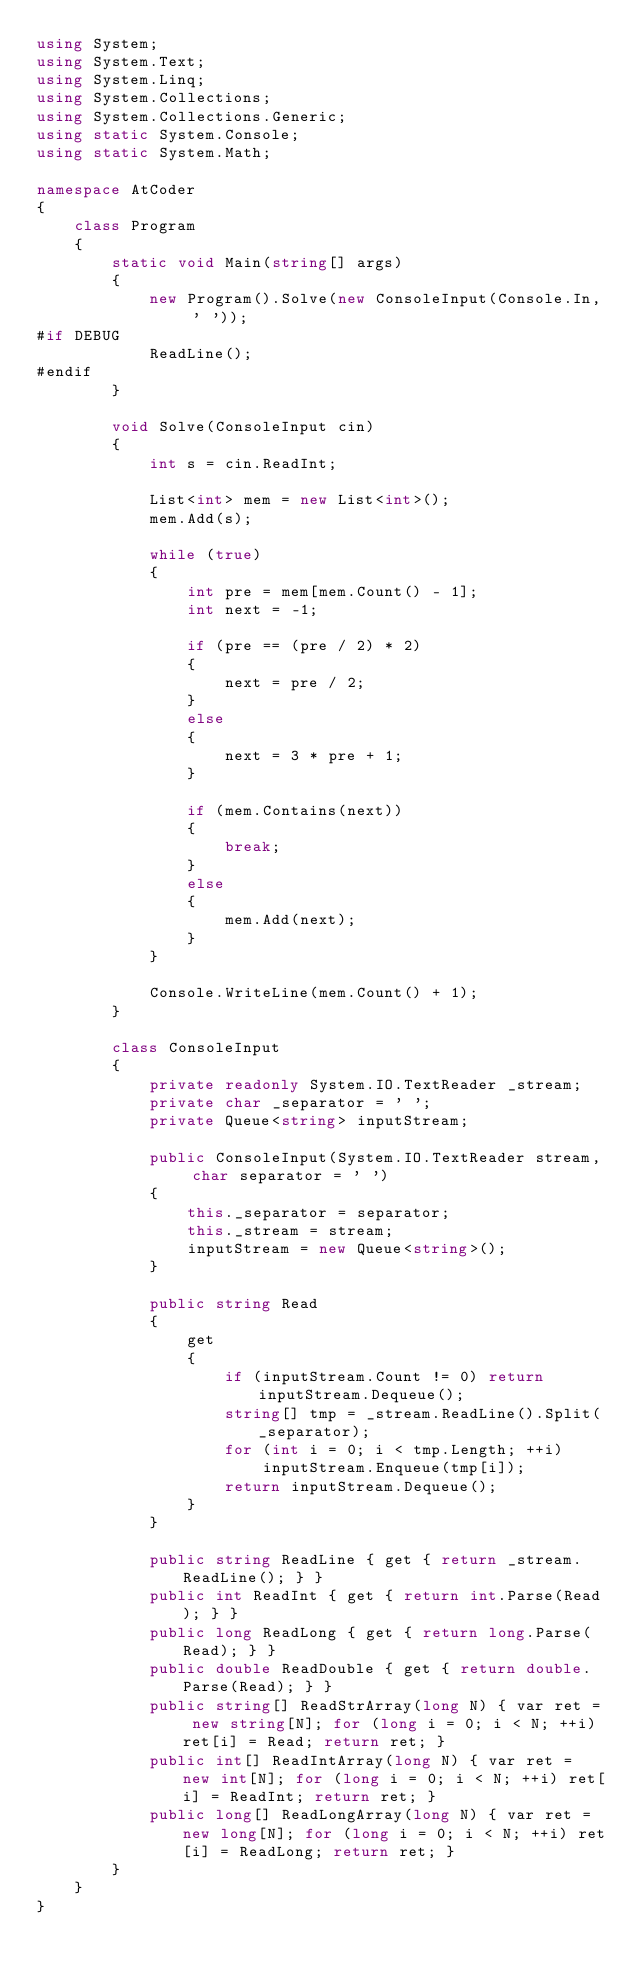<code> <loc_0><loc_0><loc_500><loc_500><_C#_>using System;
using System.Text;
using System.Linq;
using System.Collections;
using System.Collections.Generic;
using static System.Console;
using static System.Math;

namespace AtCoder
{
    class Program
    {
        static void Main(string[] args)
        {
            new Program().Solve(new ConsoleInput(Console.In, ' '));
#if DEBUG
            ReadLine();
#endif
        }

        void Solve(ConsoleInput cin)
        {
            int s = cin.ReadInt;

            List<int> mem = new List<int>();
            mem.Add(s);

            while (true)
            {
                int pre = mem[mem.Count() - 1];
                int next = -1;

                if (pre == (pre / 2) * 2)
                {
                    next = pre / 2;
                }
                else
                {
                    next = 3 * pre + 1;
                }

                if (mem.Contains(next))
                {
                    break;
                }
                else
                {
                    mem.Add(next);
                }
            }

            Console.WriteLine(mem.Count() + 1);
        }

        class ConsoleInput
        {
            private readonly System.IO.TextReader _stream;
            private char _separator = ' ';
            private Queue<string> inputStream;

            public ConsoleInput(System.IO.TextReader stream, char separator = ' ')
            {
                this._separator = separator;
                this._stream = stream;
                inputStream = new Queue<string>();
            }

            public string Read
            {
                get
                {
                    if (inputStream.Count != 0) return inputStream.Dequeue();
                    string[] tmp = _stream.ReadLine().Split(_separator);
                    for (int i = 0; i < tmp.Length; ++i)
                        inputStream.Enqueue(tmp[i]);
                    return inputStream.Dequeue();
                }
            }

            public string ReadLine { get { return _stream.ReadLine(); } }
            public int ReadInt { get { return int.Parse(Read); } }
            public long ReadLong { get { return long.Parse(Read); } }
            public double ReadDouble { get { return double.Parse(Read); } }
            public string[] ReadStrArray(long N) { var ret = new string[N]; for (long i = 0; i < N; ++i) ret[i] = Read; return ret; }
            public int[] ReadIntArray(long N) { var ret = new int[N]; for (long i = 0; i < N; ++i) ret[i] = ReadInt; return ret; }
            public long[] ReadLongArray(long N) { var ret = new long[N]; for (long i = 0; i < N; ++i) ret[i] = ReadLong; return ret; }
        }
    }
}
</code> 